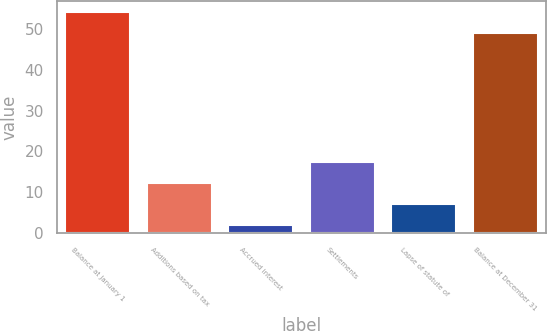<chart> <loc_0><loc_0><loc_500><loc_500><bar_chart><fcel>Balance at January 1<fcel>Additions based on tax<fcel>Accrued interest<fcel>Settlements<fcel>Lapse of statute of<fcel>Balance at December 31<nl><fcel>54.1<fcel>12.2<fcel>2<fcel>17.3<fcel>7.1<fcel>49<nl></chart> 